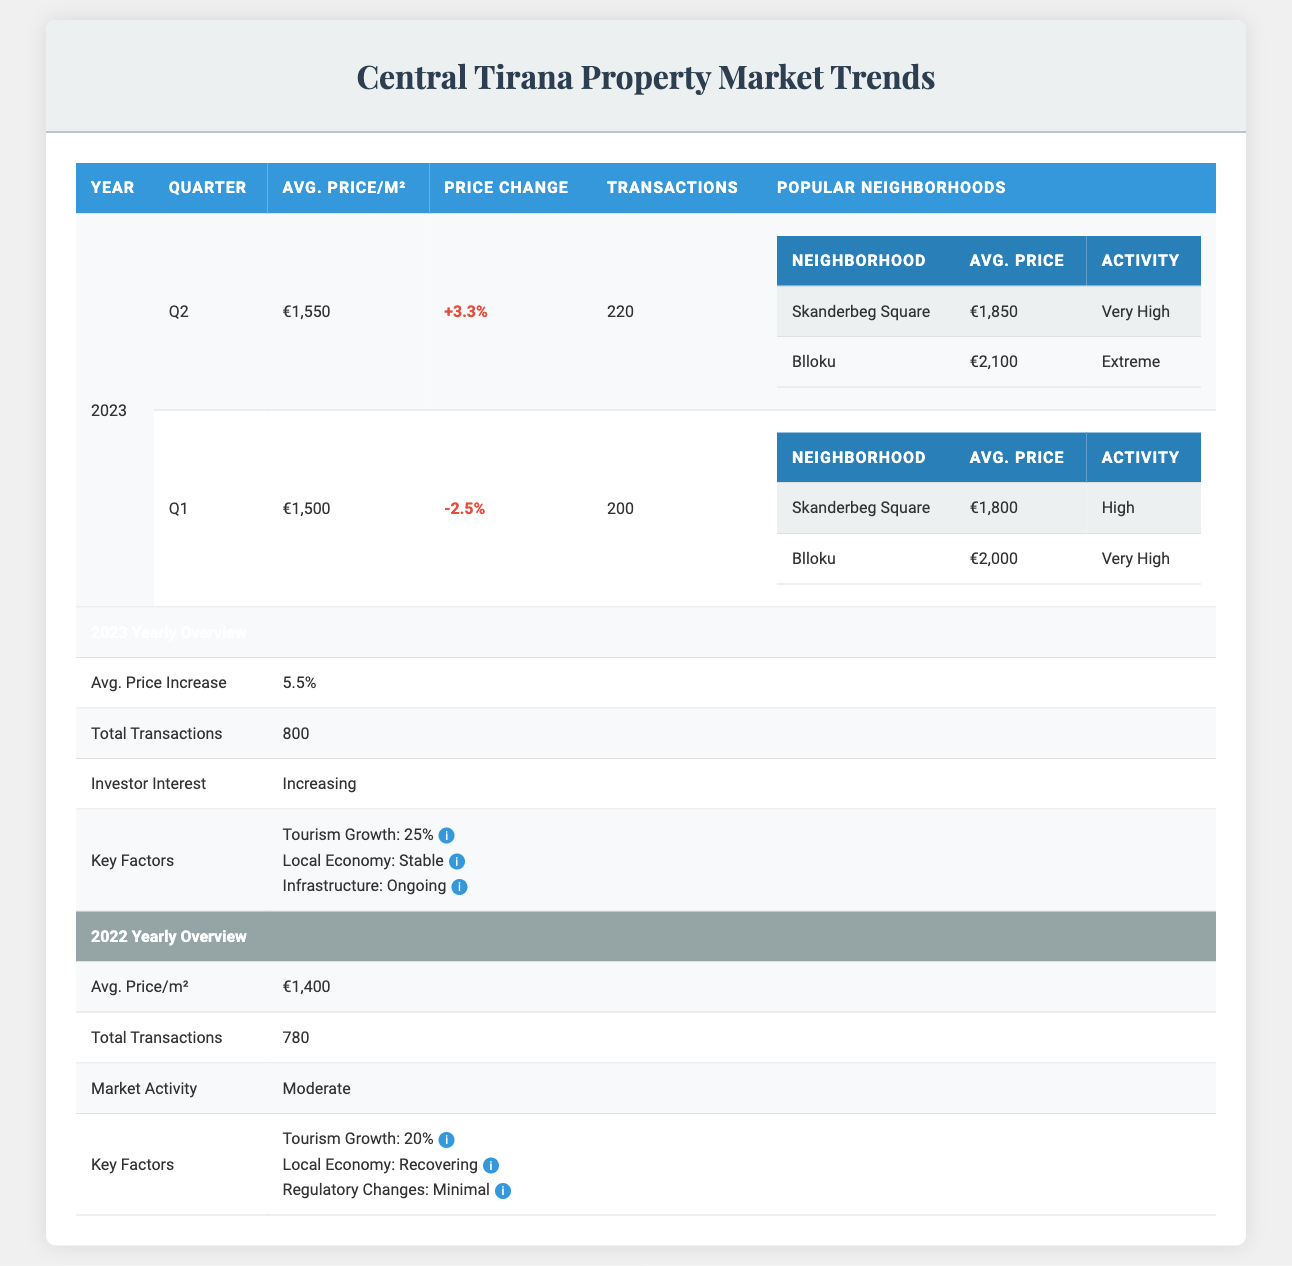What was the average price per square meter in Q1 of 2023? The table states that in Q1 of 2023, the Average Price Per Square Meter was €1,500.
Answer: €1,500 How many transactions occurred in Q2 of 2023? According to the table, the Number of Transactions in Q2 of 2023 was 220.
Answer: 220 Was there an increase in the average price per square meter from Q1 to Q2 of 2023? In Q1 of 2023, the average price was €1,500 and in Q2 it was €1,550, which indicates an increase of €50.
Answer: Yes What is the percentage change in average price per square meter from Q1 to Q2 of 2023? The percentage change can be calculated as ((1550 - 1500) / 1500) * 100 = (50 / 1500) * 100 = 3.33%, which matches the +3.3% reported for Q2.
Answer: 3.3% How much did average prices increase on a yearly basis from 2022 to 2023? In 2022, the average price per square meter was €1,400 and in 2023 it is noted to increase by 5.5%, making the new average €1,477. The effective average for 2023 is €1,477.
Answer: €77 Which neighborhood had the highest activity level in Q2 of 2023? In Q2 of 2023, the neighborhood Blloku had an activity level categorized as "Extreme."
Answer: Blloku Was the investor interest noted to be increasing or decreasing in 2023? The table indicates that investor interest for 2023 is described as "Increasing" as per the Yearly Overview section.
Answer: Increasing How many total transactions were recorded for the year 2022? The Yearly Overview for 2022 states that there were a Total Number of Transactions amounting to 780.
Answer: 780 What factors influenced the property market in 2023? The key factors influencing the market include Tourism Growth at 25%, Local Economy Stability described as Stable, and ongoing Infrastructure Development.
Answer: Tourism Growth, Local Economy Stability, Infrastructure Development What was the average price in Skanderbeg Square during Q1 of 2023? The table details that in Q1 of 2023, the Average Price in Skanderbeg Square was €1,800.
Answer: €1,800 